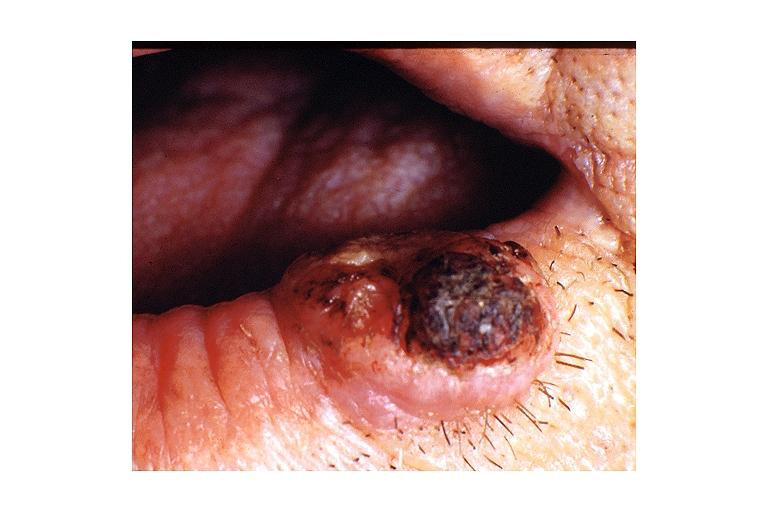does this image show keratoacanthoma?
Answer the question using a single word or phrase. Yes 